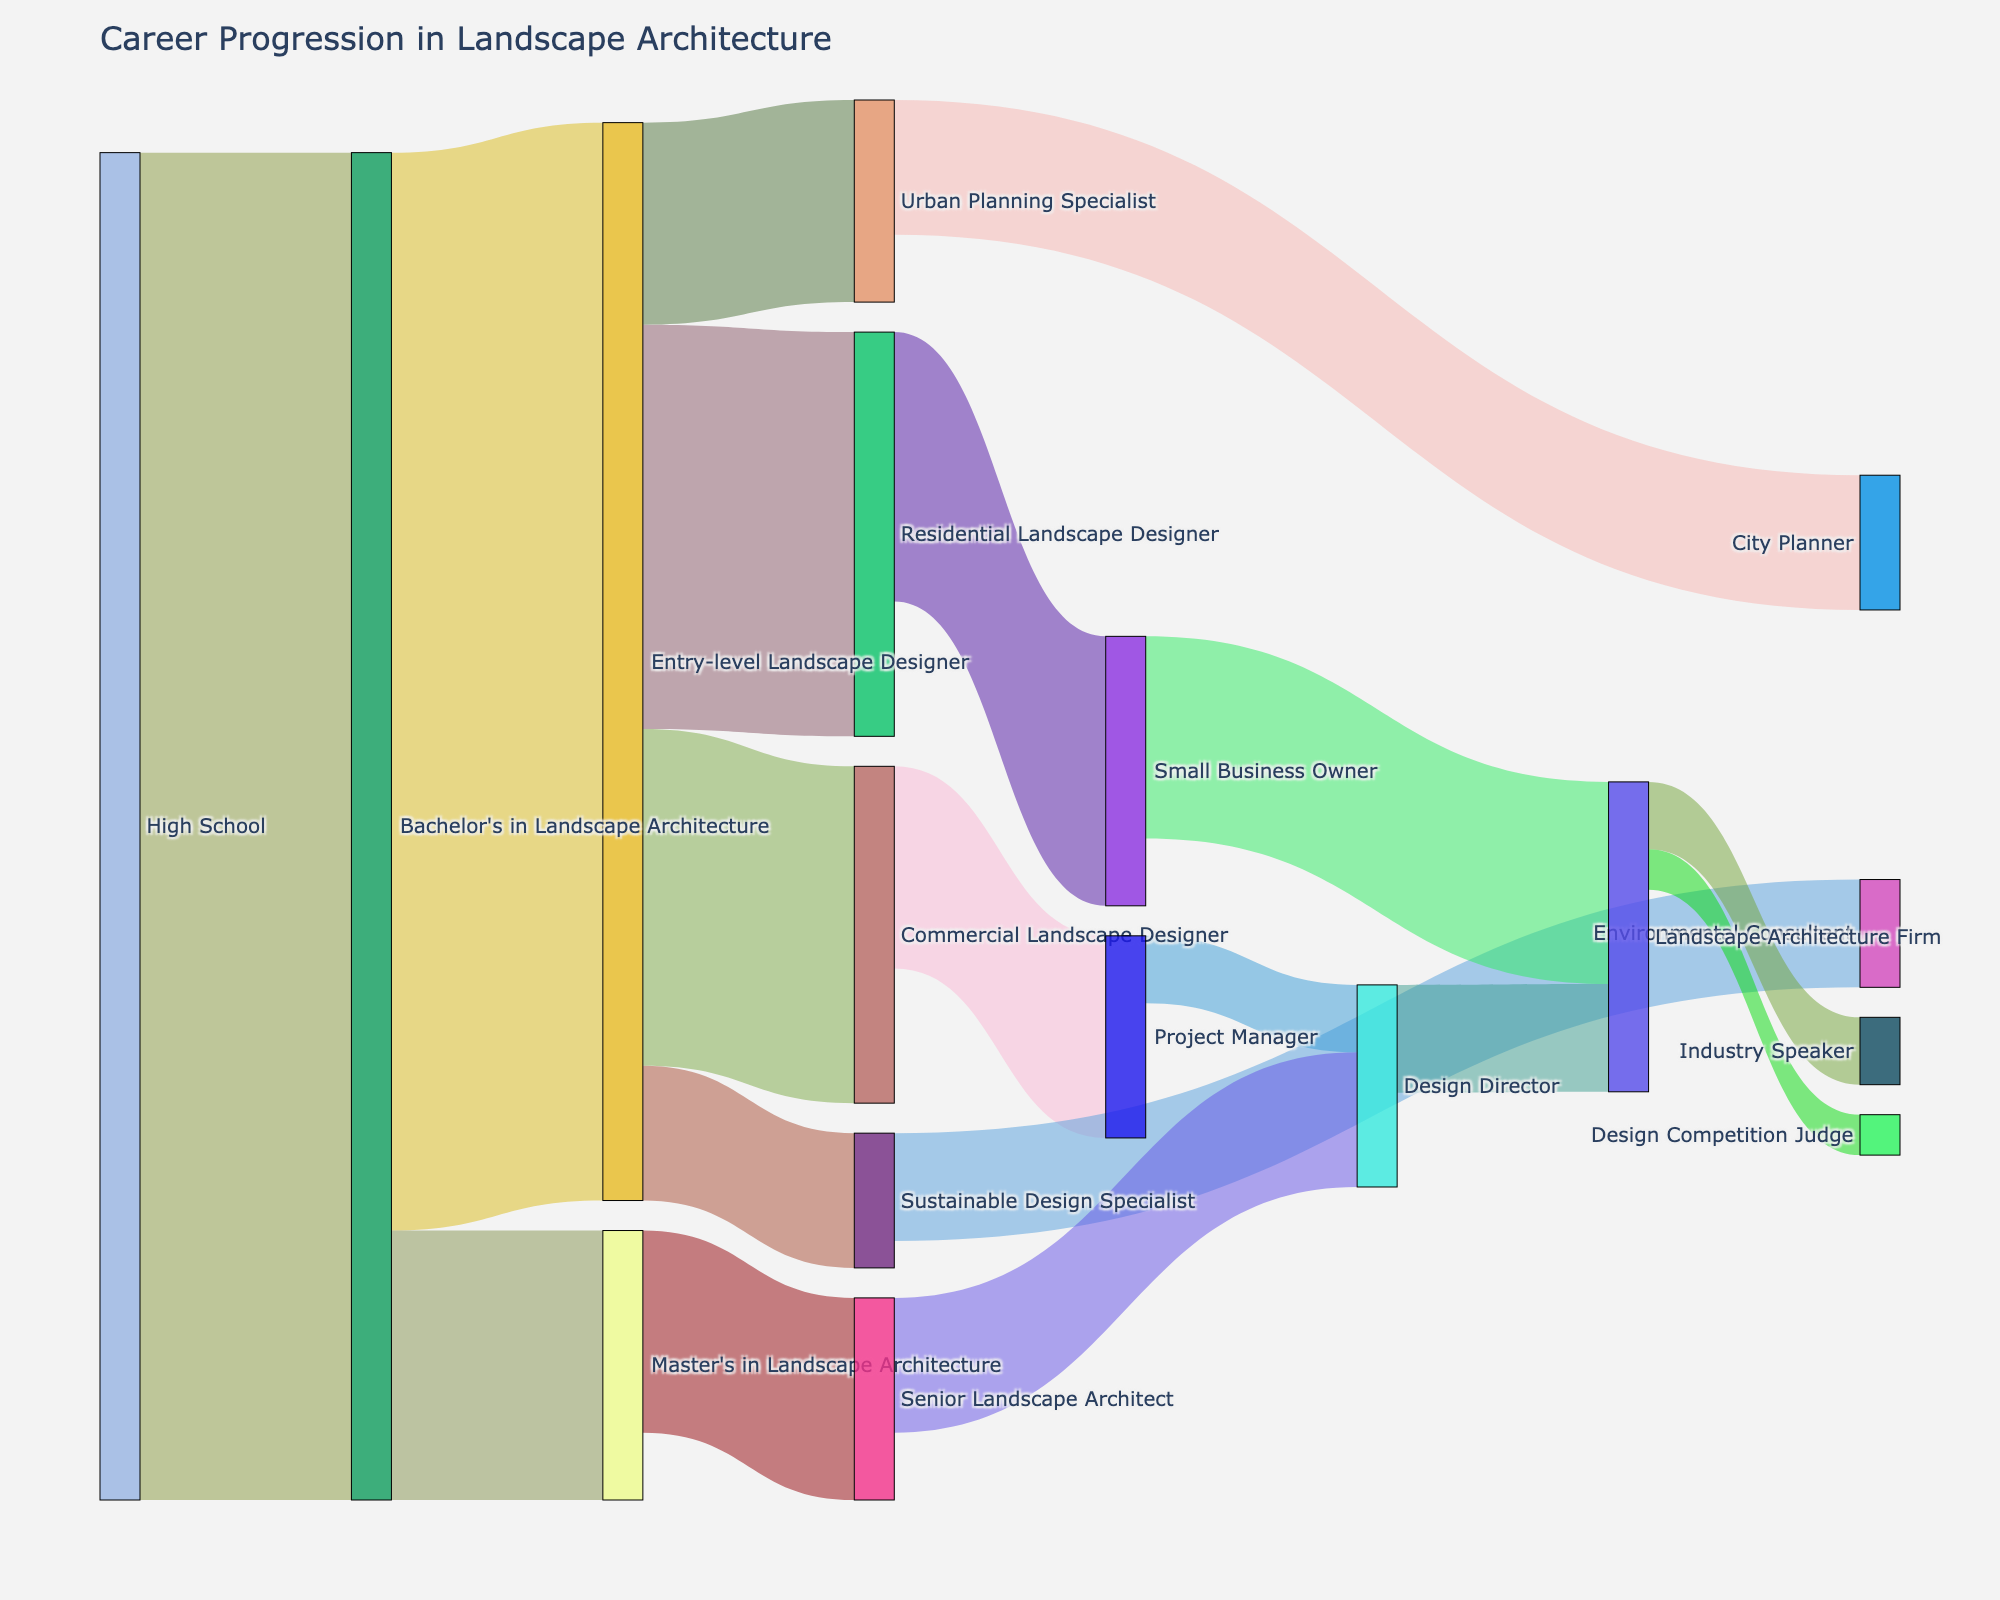What is the title of the figure? The title of the figure is displayed at the top of the Sankey diagram. It summarizes the overall purpose or focus of the diagram.
Answer: Career Progression in Landscape Architecture How many individuals progress from "High School" to "Bachelor's in Landscape Architecture"? This can be found by looking at the value associated with the link from "High School" to "Bachelor's in Landscape Architecture".
Answer: 100 Which specialization has the highest number of individuals progressing from an "Entry-level Landscape Designer"? To find this, compare the values of the links emanating from "Entry-level Landscape Designer" to various specializations such as "Residential Landscape Designer" and "Commercial Landscape Designer". The one with the highest value will have the most individuals.
Answer: Residential Landscape Designer (30) How many individuals who pursued a "Master's in Landscape Architecture" advanced to "Senior Landscape Architect"? Look for the link from "Master's in Landscape Architecture" to "Senior Landscape Architect" and identify its value.
Answer: 15 Which role sees more individuals progressing to become a "Design Director": "Senior Landscape Architect" or "Project Manager"? Compare the values of the links leading to "Design Director" from both "Senior Landscape Architect" and "Project Manager".
Answer: Senior Landscape Architect (10) What is the total number of individuals that progress from "Entry-level Landscape Designer" to any role? Sum the values of all links originating from "Entry-level Landscape Designer", specifically to "Residential Landscape Designer", "Commercial Landscape Designer", "Urban Planning Specialist", and "Sustainable Design Specialist".
Answer: 80 Between "Environmental Consultant" and "City Planner", which role has fewer individuals progressing to it? Compare the values of the links leading to "Environmental Consultant" and "City Planner", which originate from "Sustainable Design Specialist" and "Urban Planning Specialist", respectively.
Answer: Environmental Consultant (8) How many individuals transition from "Small Business Owner" to "Landscape Architecture Firm"? Look for the value of the link from "Small Business Owner" to "Landscape Architecture Firm".
Answer: 15 What is the combined number of individuals reaching "Industry Speaker" and "Design Competition Judge"? Add the values of the links from "Landscape Architecture Firm" to "Industry Speaker" and "Design Competition Judge".
Answer: 8 